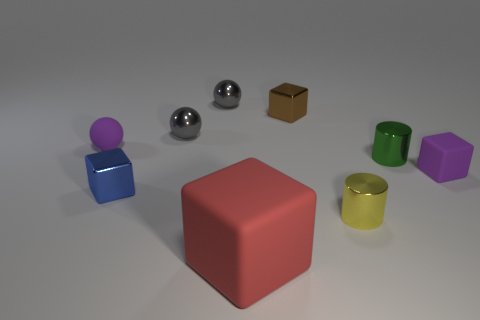Are there an equal number of big cubes that are right of the green object and rubber cubes that are to the left of the purple matte ball?
Your answer should be compact. Yes. What is the size of the rubber thing that is on the right side of the small yellow metal thing?
Provide a succinct answer. Small. Is there a small blue cylinder that has the same material as the small yellow cylinder?
Your response must be concise. No. There is a tiny cylinder that is behind the small blue shiny block; does it have the same color as the tiny rubber ball?
Give a very brief answer. No. Are there an equal number of tiny cylinders that are right of the tiny yellow metal cylinder and red matte cubes?
Offer a very short reply. Yes. Are there any tiny rubber balls that have the same color as the small rubber block?
Ensure brevity in your answer.  Yes. Is the green metal cylinder the same size as the red matte thing?
Offer a terse response. No. What size is the red rubber thing in front of the small gray metallic ball in front of the small brown metallic thing?
Offer a very short reply. Large. How big is the thing that is both in front of the small blue metallic cube and to the left of the small yellow cylinder?
Ensure brevity in your answer.  Large. How many gray rubber cylinders are the same size as the green metal cylinder?
Provide a succinct answer. 0. 